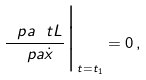Convert formula to latex. <formula><loc_0><loc_0><loc_500><loc_500>\frac { \ p a \ t L } { \ p a \dot { x } } \Big | _ { t = t _ { 1 } } = 0 \, ,</formula> 